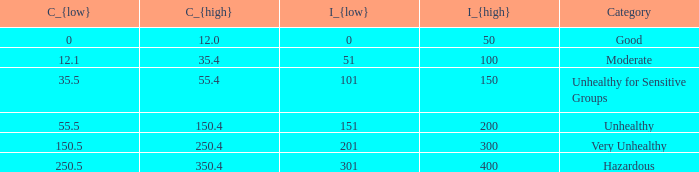5? 350.4. 